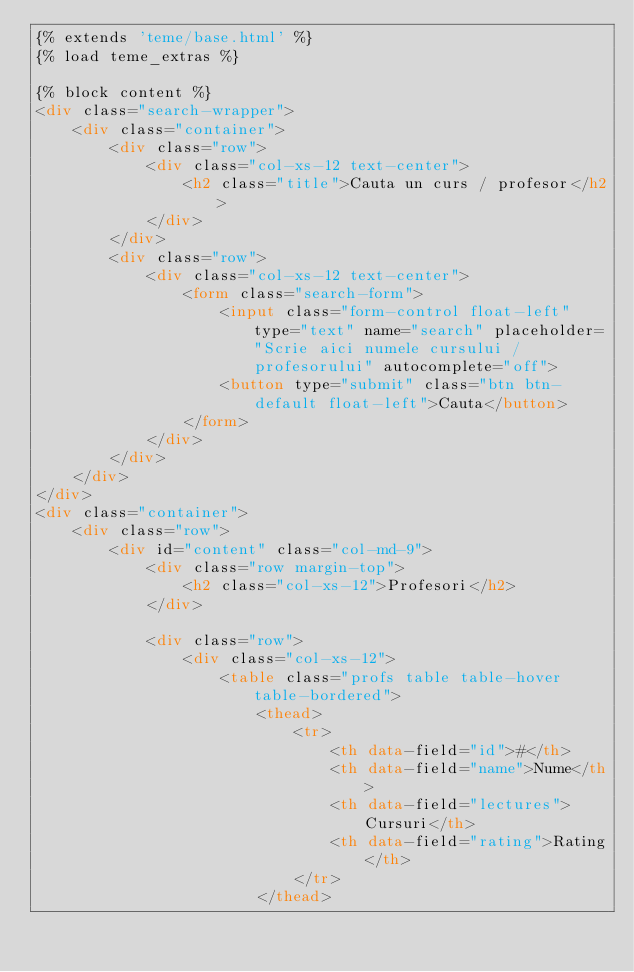Convert code to text. <code><loc_0><loc_0><loc_500><loc_500><_HTML_>{% extends 'teme/base.html' %}
{% load teme_extras %}

{% block content %}
<div class="search-wrapper">
    <div class="container">
        <div class="row">
            <div class="col-xs-12 text-center">
                <h2 class="title">Cauta un curs / profesor</h2>
            </div>
        </div>
        <div class="row">
            <div class="col-xs-12 text-center">
                <form class="search-form">
                    <input class="form-control float-left" type="text" name="search" placeholder="Scrie aici numele cursului / profesorului" autocomplete="off">
                    <button type="submit" class="btn btn-default float-left">Cauta</button>
                </form>
            </div>
        </div>
    </div>
</div>
<div class="container">
    <div class="row">
        <div id="content" class="col-md-9">
            <div class="row margin-top">
                <h2 class="col-xs-12">Profesori</h2>
            </div>

            <div class="row">
                <div class="col-xs-12">
                    <table class="profs table table-hover table-bordered">
                        <thead>
                            <tr>
                                <th data-field="id">#</th>
                                <th data-field="name">Nume</th>
                                <th data-field="lectures">Cursuri</th>
                                <th data-field="rating">Rating</th>
                            </tr>
                        </thead></code> 